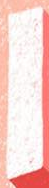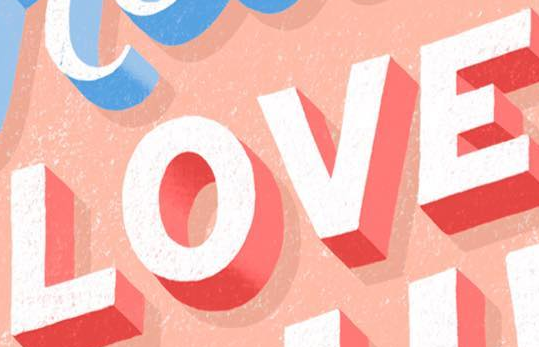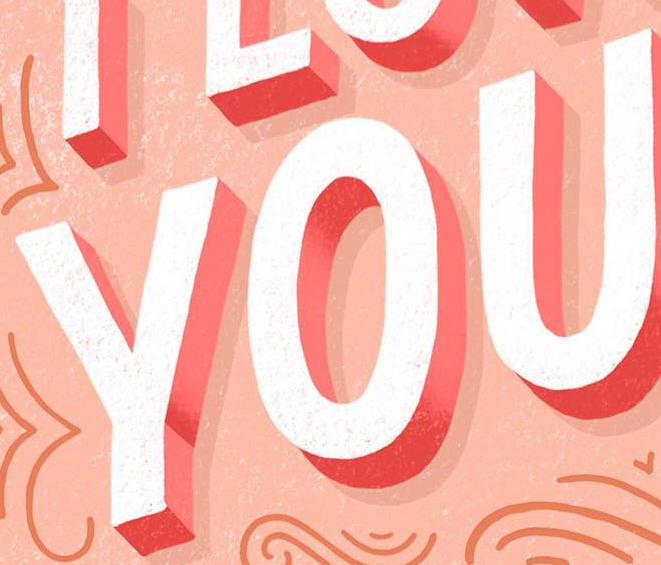Transcribe the words shown in these images in order, separated by a semicolon. I; LOVE; YOU 